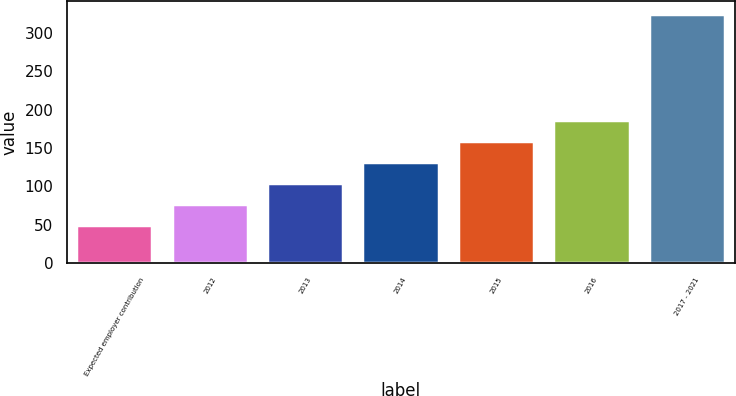Convert chart. <chart><loc_0><loc_0><loc_500><loc_500><bar_chart><fcel>Expected employer contribution<fcel>2012<fcel>2013<fcel>2014<fcel>2015<fcel>2016<fcel>2017 - 2021<nl><fcel>49<fcel>76.6<fcel>104.2<fcel>131.8<fcel>159.4<fcel>187<fcel>325<nl></chart> 